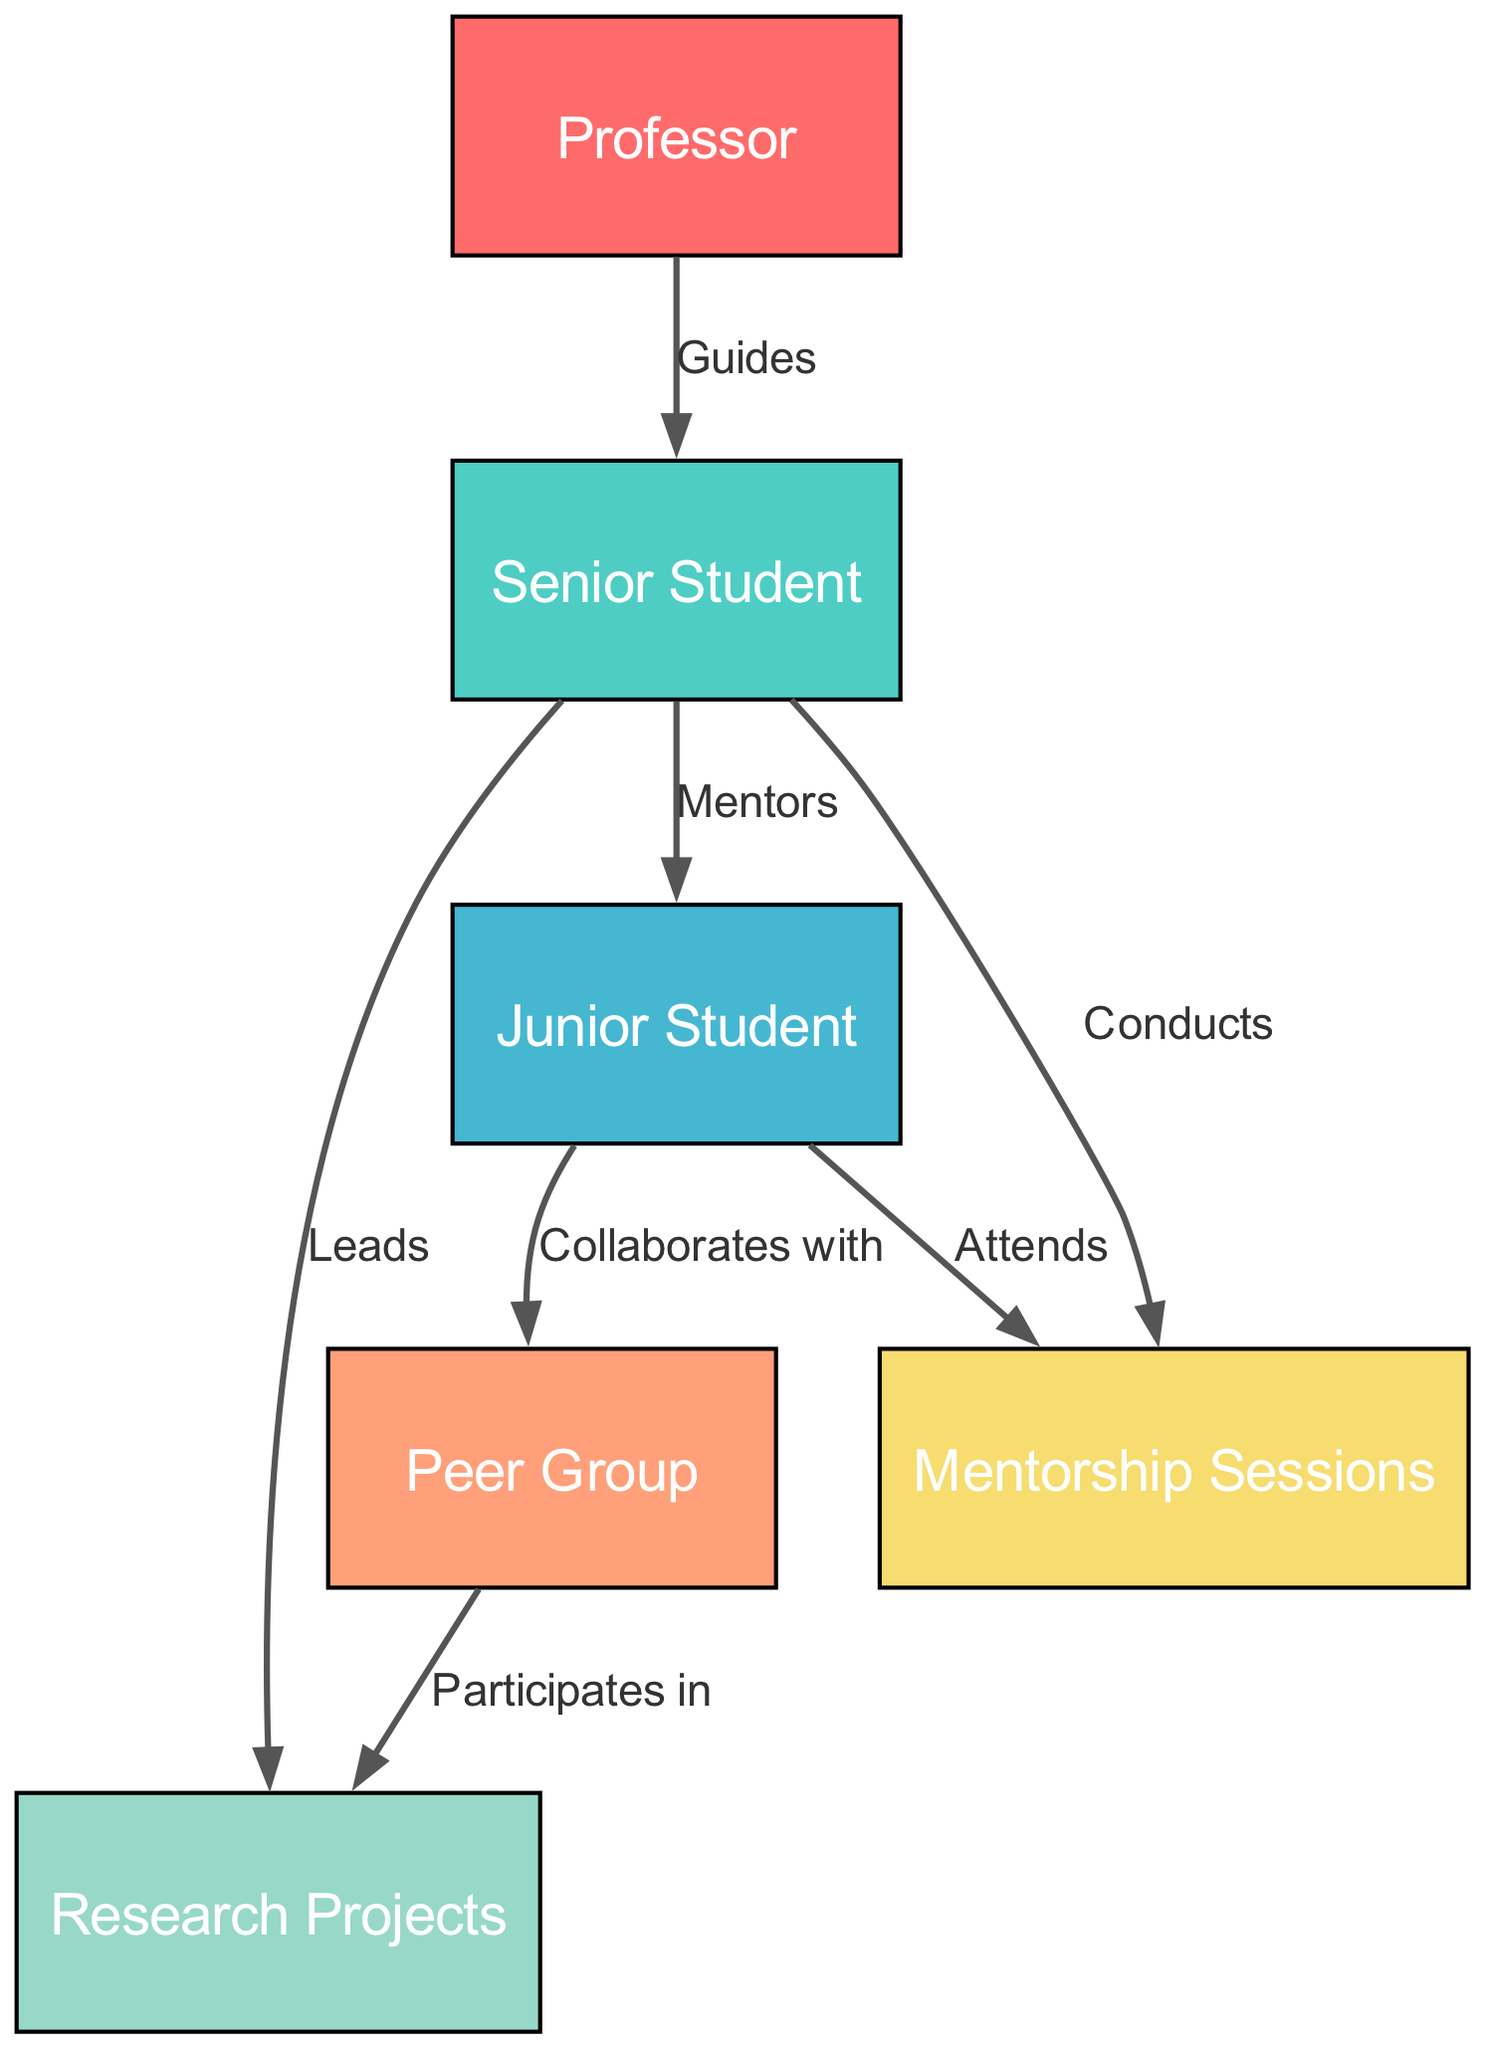What is the role of the senior student in this collaboration network? The senior student has two defined roles in the network. First, they guide the professor, and second, they act as a mentor to the junior student. This is indicated in the edges labeled "Guides" and "Mentors" leading from the senior student node to the professor and junior student nodes, respectively.
Answer: Guides and Mentors How many nodes are present in this diagram? The diagram lists a total of six nodes: Professor, Senior Student, Junior Student, Peer Group, Research Projects, and Mentorship Sessions. Counting each unique id under the "nodes" section confirms there are six distinct entities represented.
Answer: 6 Which node do junior students collaborate with? According to the edges connecting nodes in the diagram, junior students collaborate with the peer group, as indicated by the edge labeled "Collaborates with" that connects the junior student to the peer group.
Answer: Peer Group What is the primary outcome of senior students guiding junior students? The primary outcome is the mentorship relationship where senior students mentor junior students, facilitating their academic development and involvement in peer groups and research projects. This is seen through the "Mentors" edge connecting senior students to junior students, signifying a leadership and guidance role.
Answer: Mentorship How do junior students engage in collaborative projects? Junior students engage in collaborative projects by collaborating with peer groups, as depicted by the directed edge labeled "Collaborates with" that links the junior student node to the peer group node. Furthermore, participation in research projects is a subsequent step where peer groups are involved, implying that interactions foster collaborative efforts in research.
Answer: Through Peer Group Which two nodes have mentorship sessions connecting them? The mentorship sessions connect two nodes: senior students and junior students. This is evident from the edges "Attends" and "Conducts," which show that both senior students conduct and junior students attend mentorship sessions, demonstrating the active engagement in mentoring.
Answer: Senior Student and Junior Student What is the function of the peer group in the context of research projects? The function of the peer group in the context of research projects is to participate in them. This is illustrated through the directed edge labeled "Participates in," which connects the peer group node to the research projects node, indicating that peer groups play an active role in contributing to research efforts.
Answer: Participates in How many total edges are represented in this diagram? The total number of edges present in the diagram is seven. This can be verified by counting each of the relationships defined in the "edges" section, which showcases the connections and interactions among the nodes.
Answer: 7 